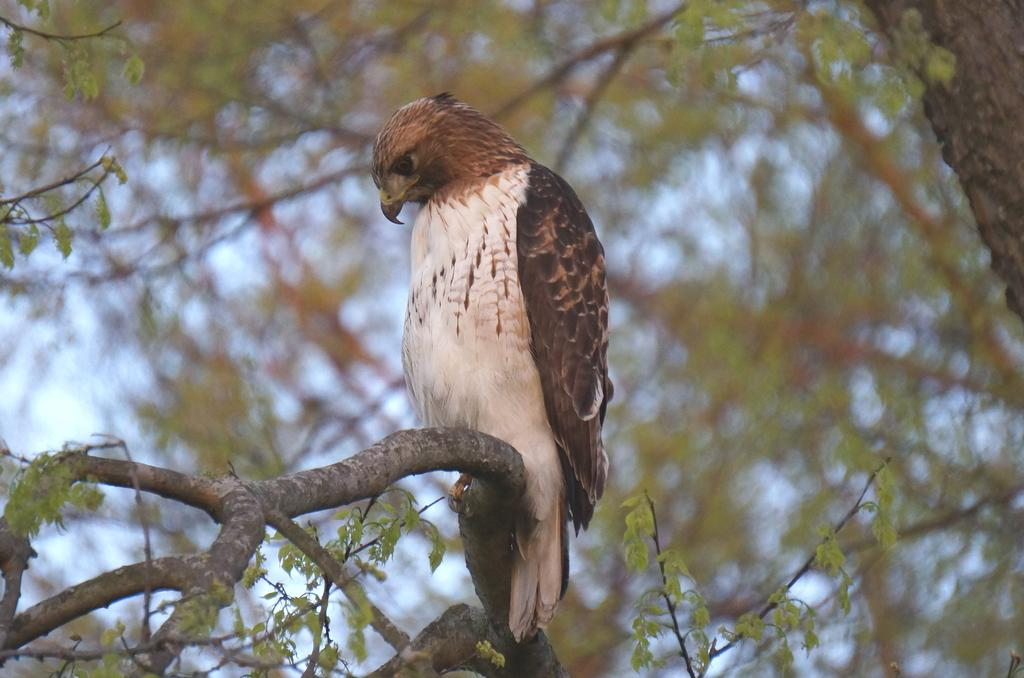What type of animal can be seen in the image? There is a bird in the image. Where is the bird located in the image? The bird is sitting on a branch of a tree. What else is present in the image besides the bird? There is a tree in the image. Can you describe the background of the image? The background of the image is blurred. What type of fruit is hanging from the tree in the image? There is no fruit visible in the image; only the bird and the tree are present. 